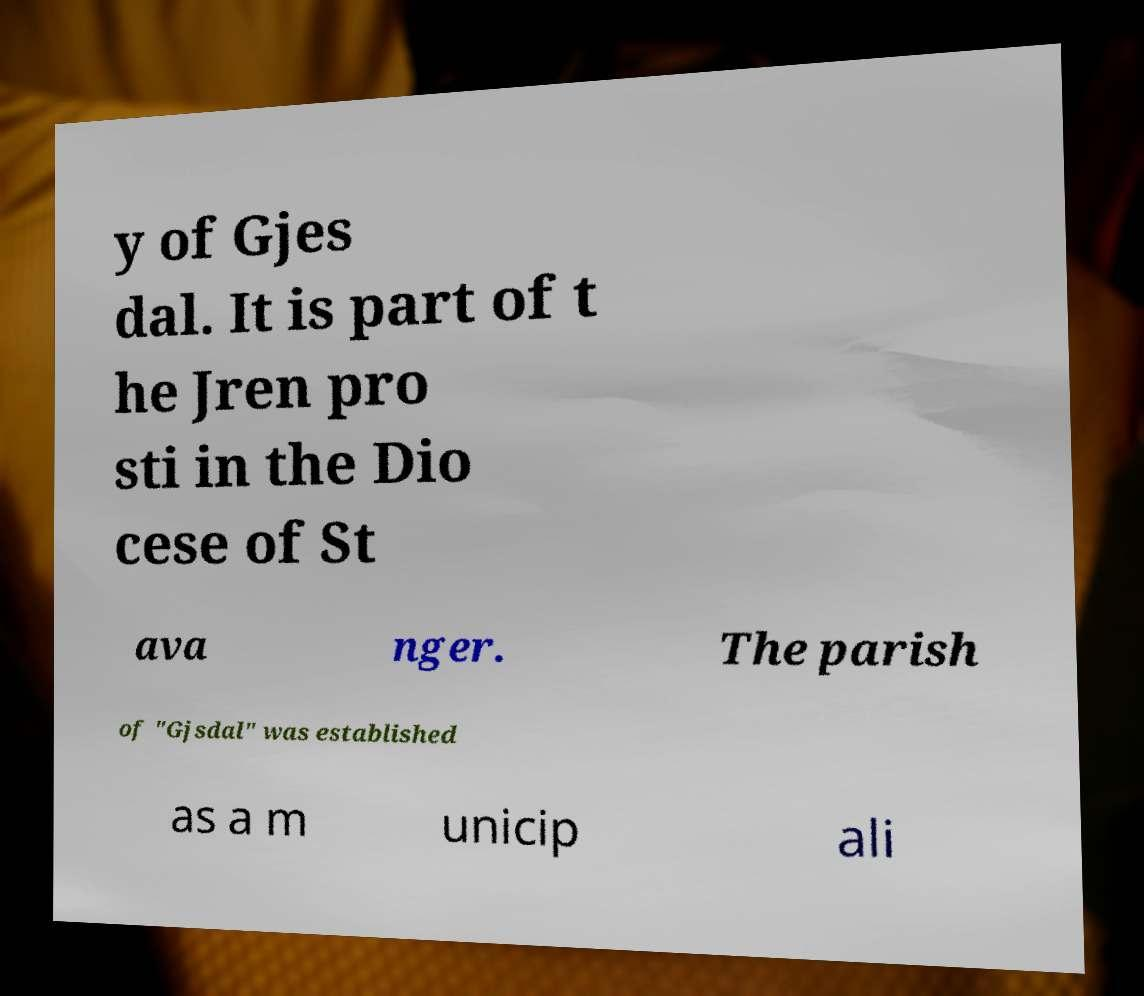Could you extract and type out the text from this image? y of Gjes dal. It is part of t he Jren pro sti in the Dio cese of St ava nger. The parish of "Gjsdal" was established as a m unicip ali 